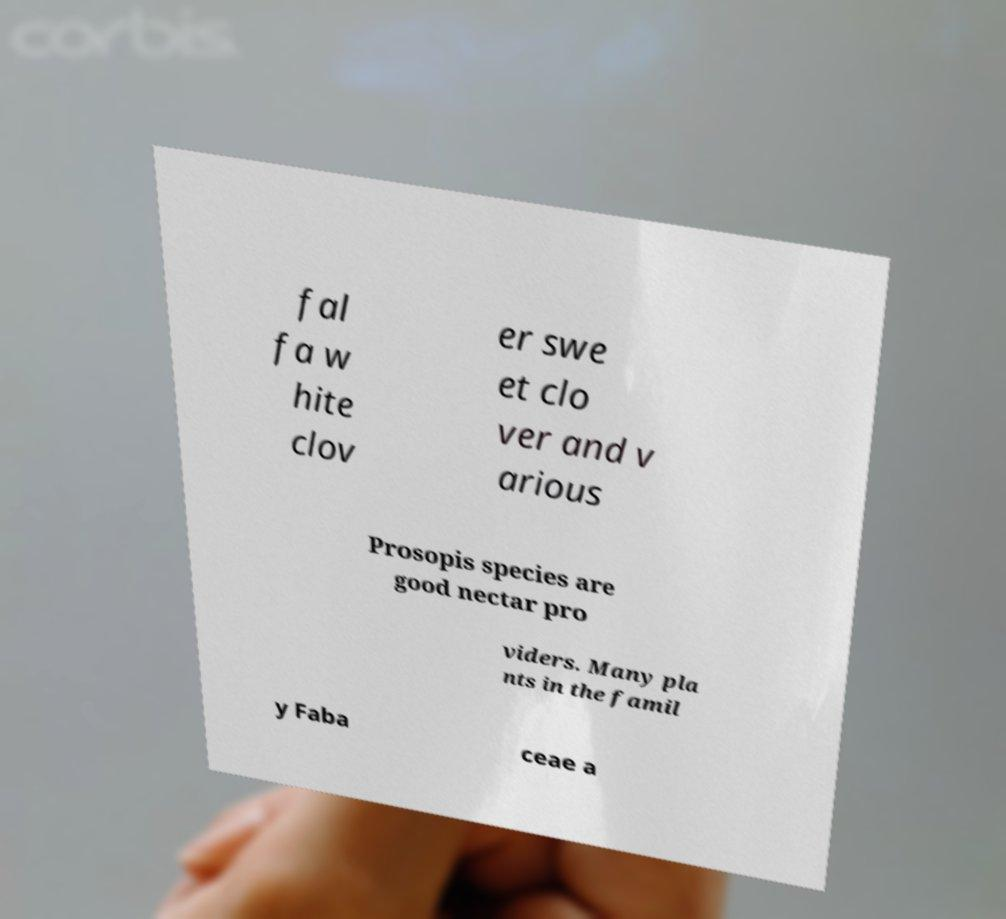Can you read and provide the text displayed in the image?This photo seems to have some interesting text. Can you extract and type it out for me? fal fa w hite clov er swe et clo ver and v arious Prosopis species are good nectar pro viders. Many pla nts in the famil y Faba ceae a 